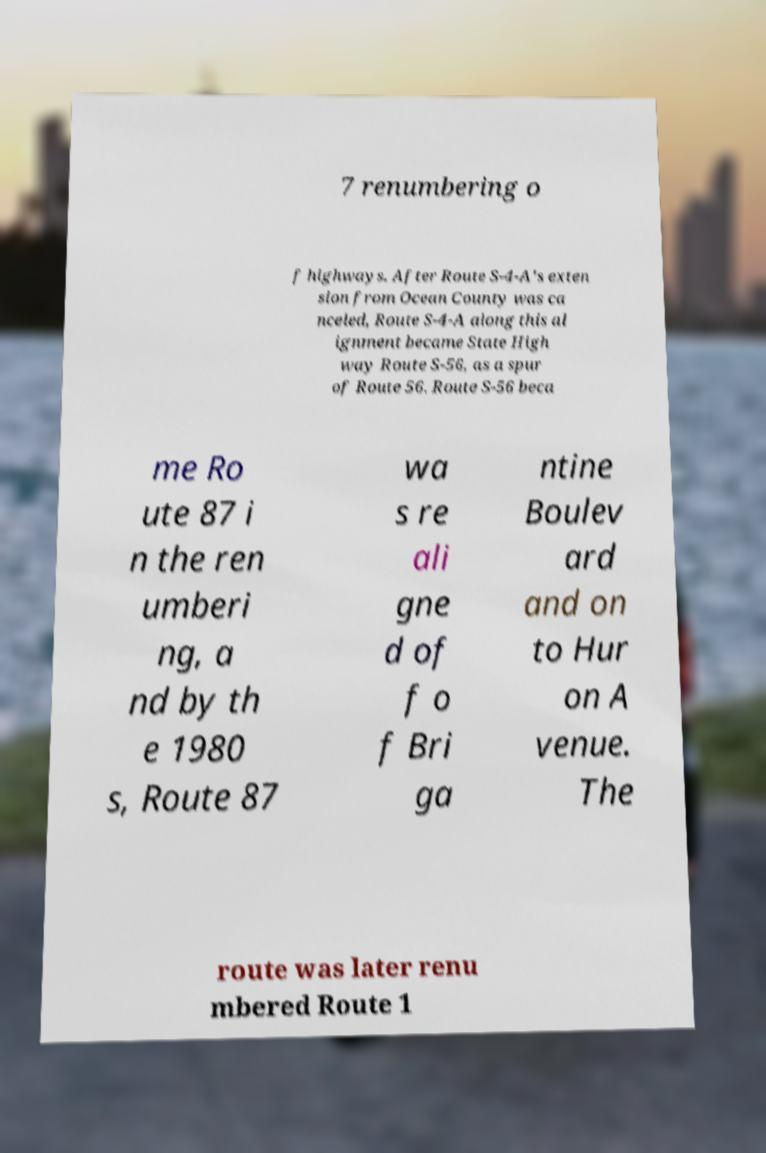What messages or text are displayed in this image? I need them in a readable, typed format. 7 renumbering o f highways. After Route S-4-A's exten sion from Ocean County was ca nceled, Route S-4-A along this al ignment became State High way Route S-56, as a spur of Route 56. Route S-56 beca me Ro ute 87 i n the ren umberi ng, a nd by th e 1980 s, Route 87 wa s re ali gne d of f o f Bri ga ntine Boulev ard and on to Hur on A venue. The route was later renu mbered Route 1 